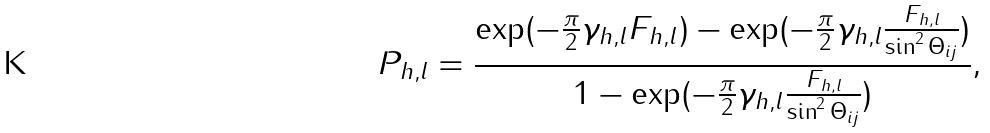Convert formula to latex. <formula><loc_0><loc_0><loc_500><loc_500>P _ { h , l } = \frac { \exp ( - \frac { \pi } { 2 } \gamma _ { h , l } F _ { h , l } ) - \exp ( - \frac { \pi } { 2 } \gamma _ { h , l } \frac { F _ { h , l } } { \sin ^ { 2 } \Theta _ { i j } } ) } { 1 - \exp ( - \frac { \pi } { 2 } \gamma _ { h , l } \frac { F _ { h , l } } { \sin ^ { 2 } \Theta _ { i j } } ) } ,</formula> 